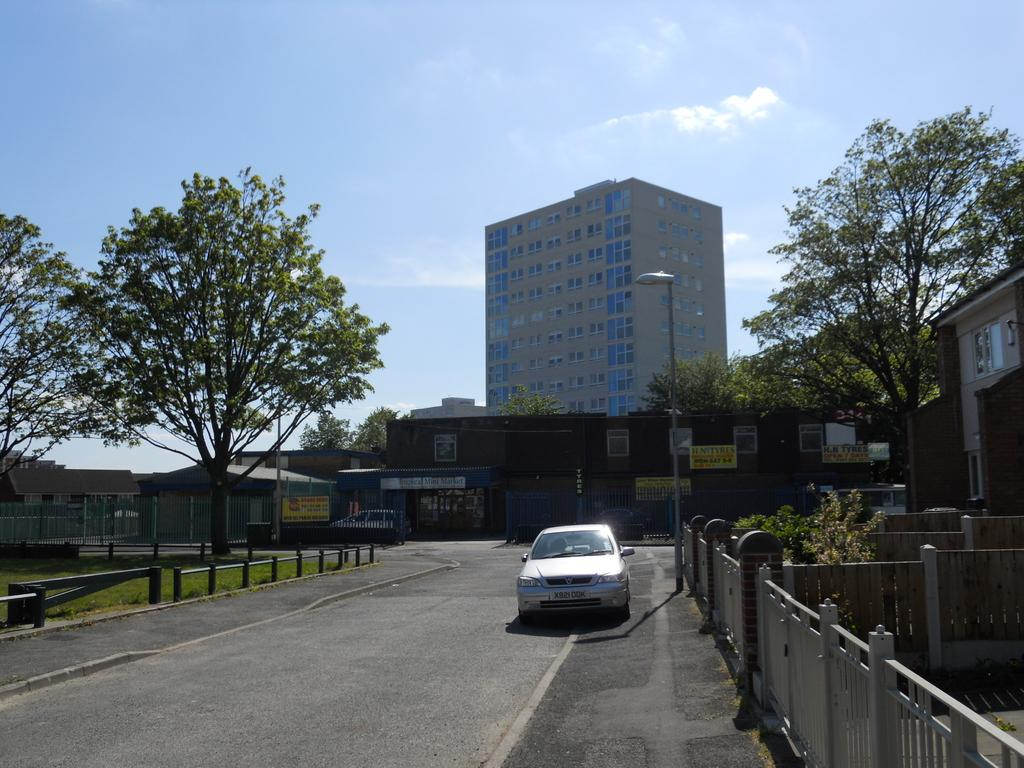What is the main feature in the center of the image? There is a road in the center of the image. What is on the road in the image? There is a car on the road. What can be seen in the background of the image? There are buildings and trees in the background of the image. How many legs can be seen on the vegetable in the image? There is no vegetable present in the image, and therefore no legs can be seen on it. 